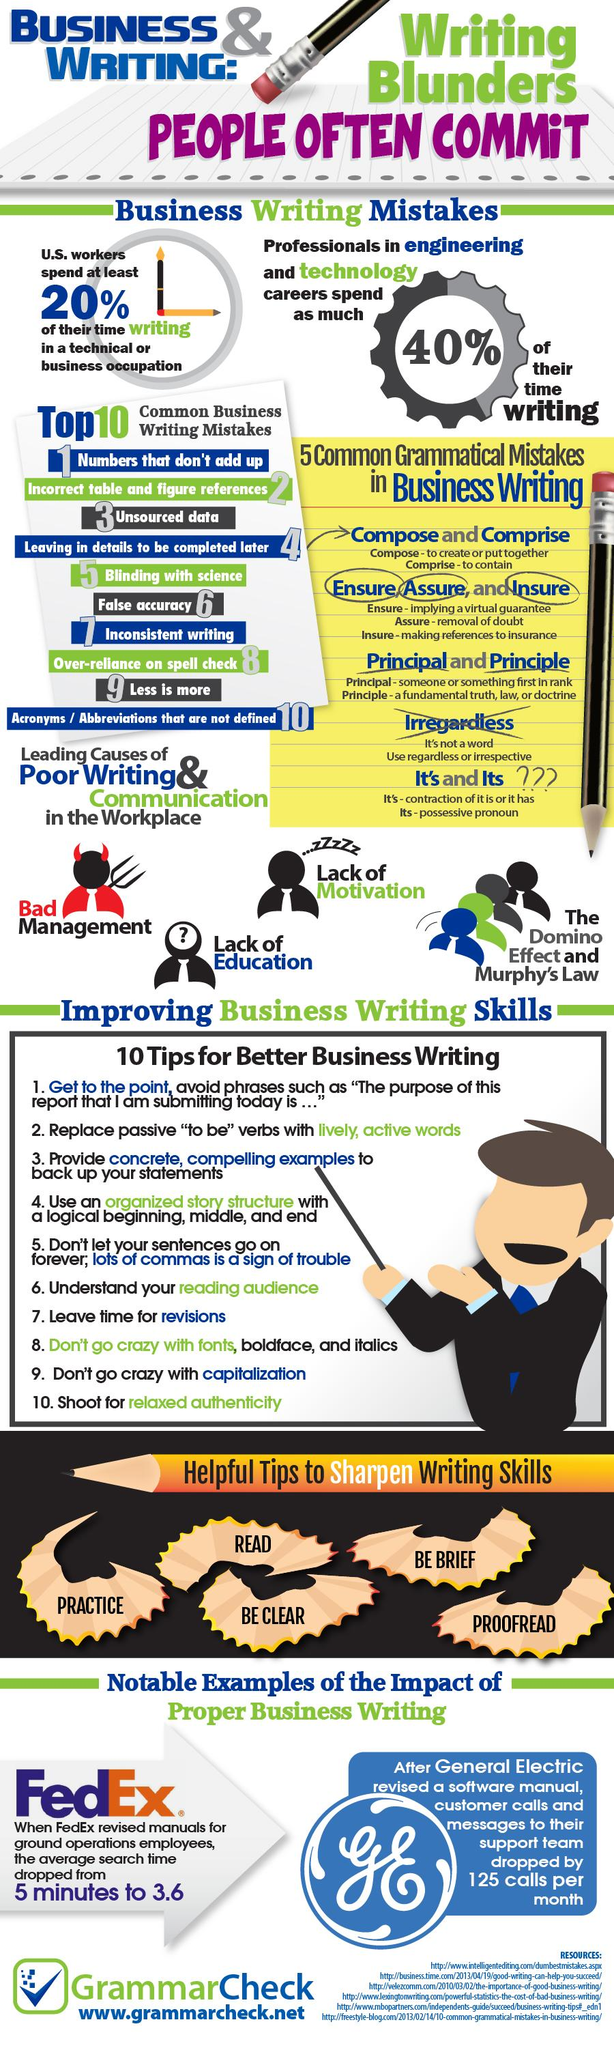Point out several critical features in this image. Definitions of acronyms or abbreviations that have not been provided are the least common business writing mistake that occurs. What is the most common business writing mistake that occurs, specifically unsourced data? The average search time decreased by 5 minutes when FedEx revised their manuals for ground operations employees from 3.6 hours to 3.6 minutes. According to estimates, professionals in engineering and technology careers spend approximately 40% of their time writing. 